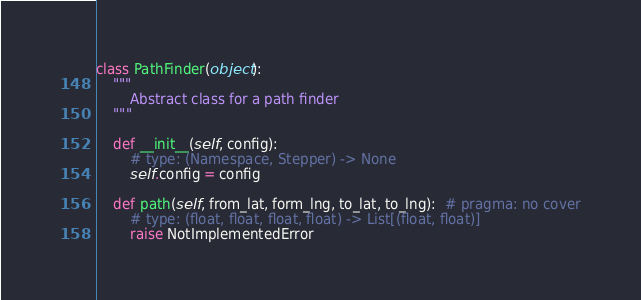<code> <loc_0><loc_0><loc_500><loc_500><_Python_>class PathFinder(object):
    """
        Abstract class for a path finder
    """

    def __init__(self, config):
        # type: (Namespace, Stepper) -> None
        self.config = config

    def path(self, from_lat, form_lng, to_lat, to_lng):  # pragma: no cover
        # type: (float, float, float, float) -> List[(float, float)]
        raise NotImplementedError
</code> 